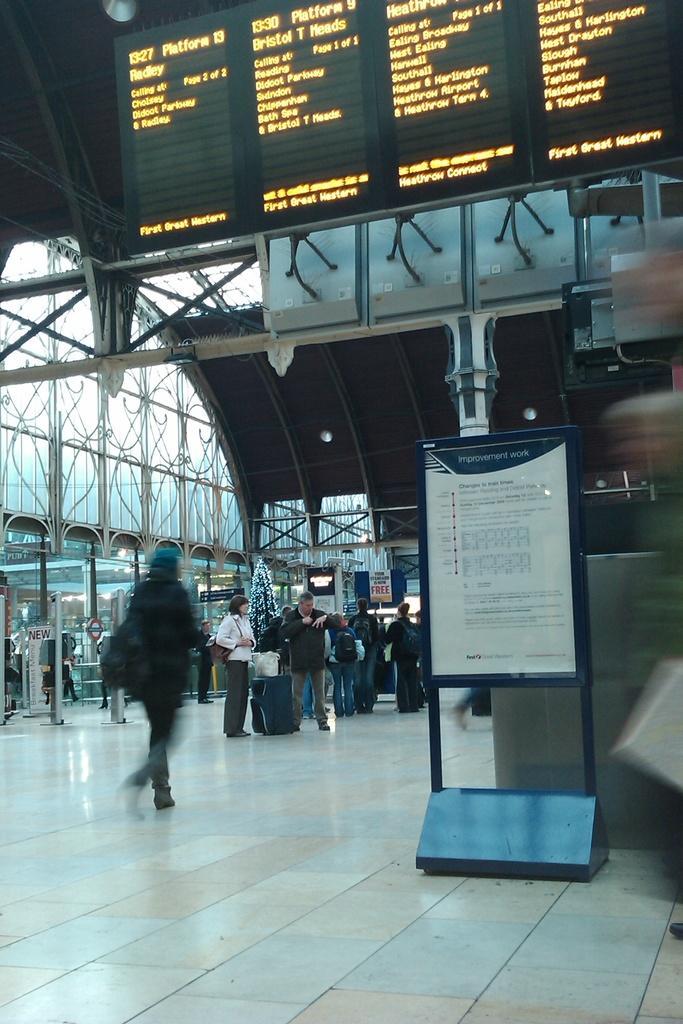In one or two sentences, can you explain what this image depicts? In this image I can see few persons standing on the floor. At the top I can see some text. I can see a board with some text on it. 